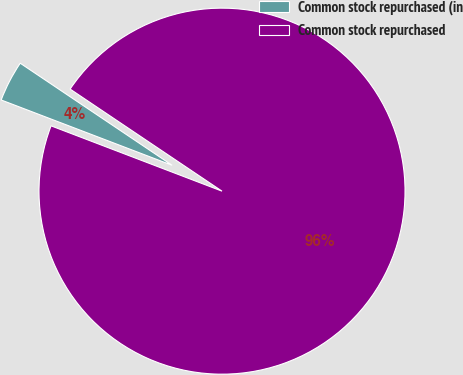Convert chart. <chart><loc_0><loc_0><loc_500><loc_500><pie_chart><fcel>Common stock repurchased (in<fcel>Common stock repurchased<nl><fcel>3.61%<fcel>96.39%<nl></chart> 